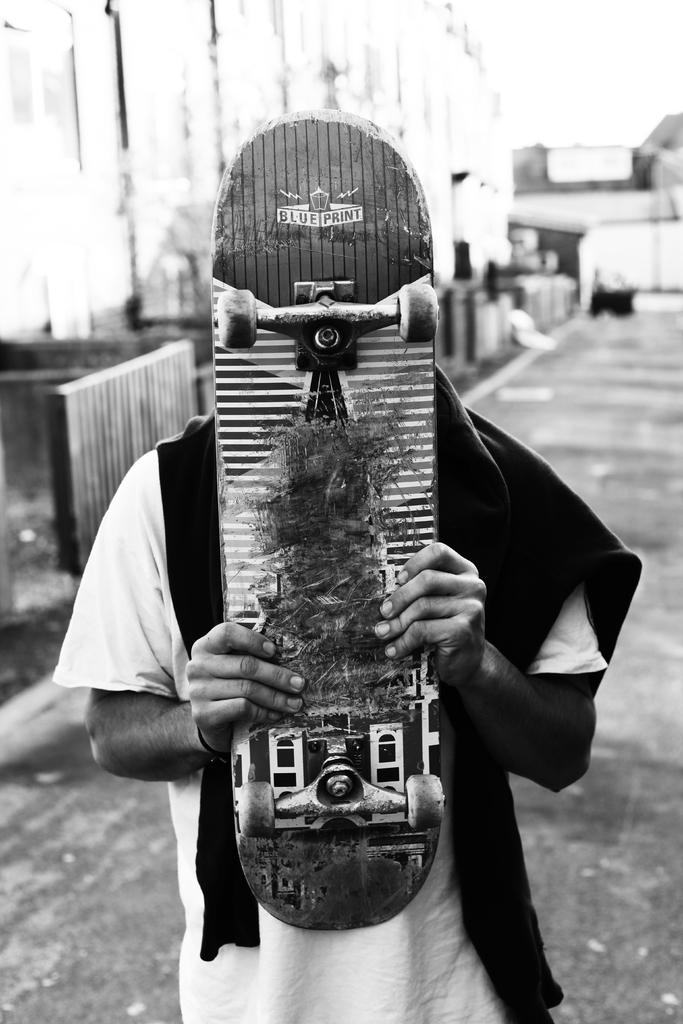What is the color scheme of the image? The image is black and white. What is the person in the image doing? The person is standing and holding a skateboard. What can be seen in the background of the image? There are buildings visible in the image. How is the background of the image depicted? The background of the image is blurred. What type of worm can be seen crawling on the person's skateboard in the image? There is no worm present on the person's skateboard in the image. What time of day is it in the image, given the morning light? The image is black and white, so it is not possible to determine the time of day based on the lighting. 